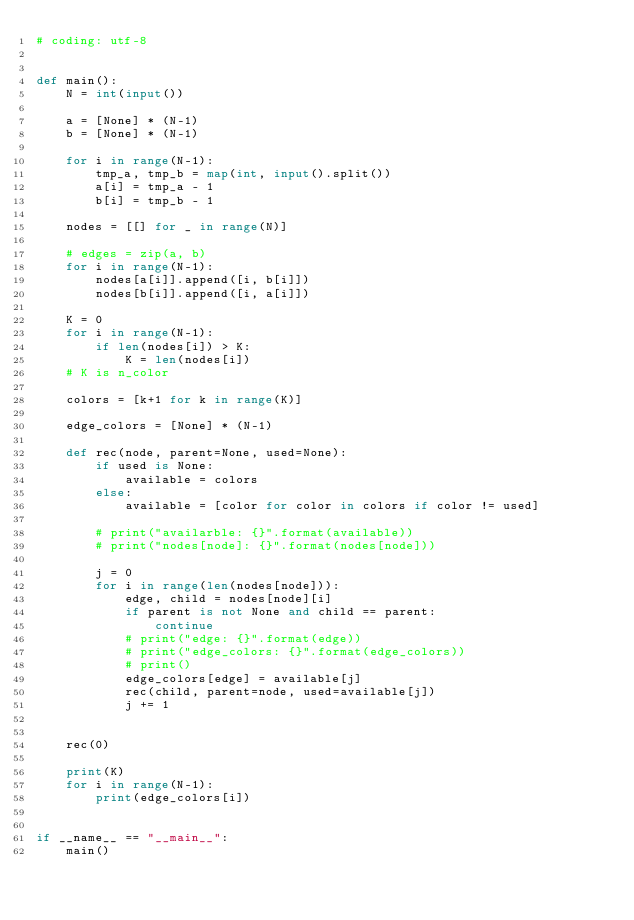<code> <loc_0><loc_0><loc_500><loc_500><_Python_># coding: utf-8


def main():
    N = int(input())

    a = [None] * (N-1)
    b = [None] * (N-1)

    for i in range(N-1):
        tmp_a, tmp_b = map(int, input().split())
        a[i] = tmp_a - 1
        b[i] = tmp_b - 1

    nodes = [[] for _ in range(N)]

    # edges = zip(a, b)
    for i in range(N-1):
        nodes[a[i]].append([i, b[i]])
        nodes[b[i]].append([i, a[i]])

    K = 0
    for i in range(N-1):
        if len(nodes[i]) > K:
            K = len(nodes[i])
    # K is n_color

    colors = [k+1 for k in range(K)]

    edge_colors = [None] * (N-1)

    def rec(node, parent=None, used=None):
        if used is None:
            available = colors
        else:
            available = [color for color in colors if color != used]

        # print("availarble: {}".format(available))
        # print("nodes[node]: {}".format(nodes[node]))

        j = 0
        for i in range(len(nodes[node])):
            edge, child = nodes[node][i]
            if parent is not None and child == parent:
                continue
            # print("edge: {}".format(edge))
            # print("edge_colors: {}".format(edge_colors))
            # print()
            edge_colors[edge] = available[j]
            rec(child, parent=node, used=available[j])
            j += 1


    rec(0)

    print(K)
    for i in range(N-1):
        print(edge_colors[i])


if __name__ == "__main__":
    main()
</code> 